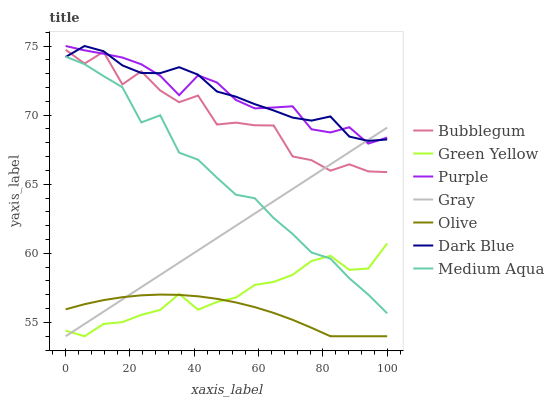Does Olive have the minimum area under the curve?
Answer yes or no. Yes. Does Dark Blue have the maximum area under the curve?
Answer yes or no. Yes. Does Purple have the minimum area under the curve?
Answer yes or no. No. Does Purple have the maximum area under the curve?
Answer yes or no. No. Is Gray the smoothest?
Answer yes or no. Yes. Is Bubblegum the roughest?
Answer yes or no. Yes. Is Purple the smoothest?
Answer yes or no. No. Is Purple the roughest?
Answer yes or no. No. Does Gray have the lowest value?
Answer yes or no. Yes. Does Purple have the lowest value?
Answer yes or no. No. Does Dark Blue have the highest value?
Answer yes or no. Yes. Does Bubblegum have the highest value?
Answer yes or no. No. Is Medium Aqua less than Bubblegum?
Answer yes or no. Yes. Is Bubblegum greater than Green Yellow?
Answer yes or no. Yes. Does Gray intersect Bubblegum?
Answer yes or no. Yes. Is Gray less than Bubblegum?
Answer yes or no. No. Is Gray greater than Bubblegum?
Answer yes or no. No. Does Medium Aqua intersect Bubblegum?
Answer yes or no. No. 